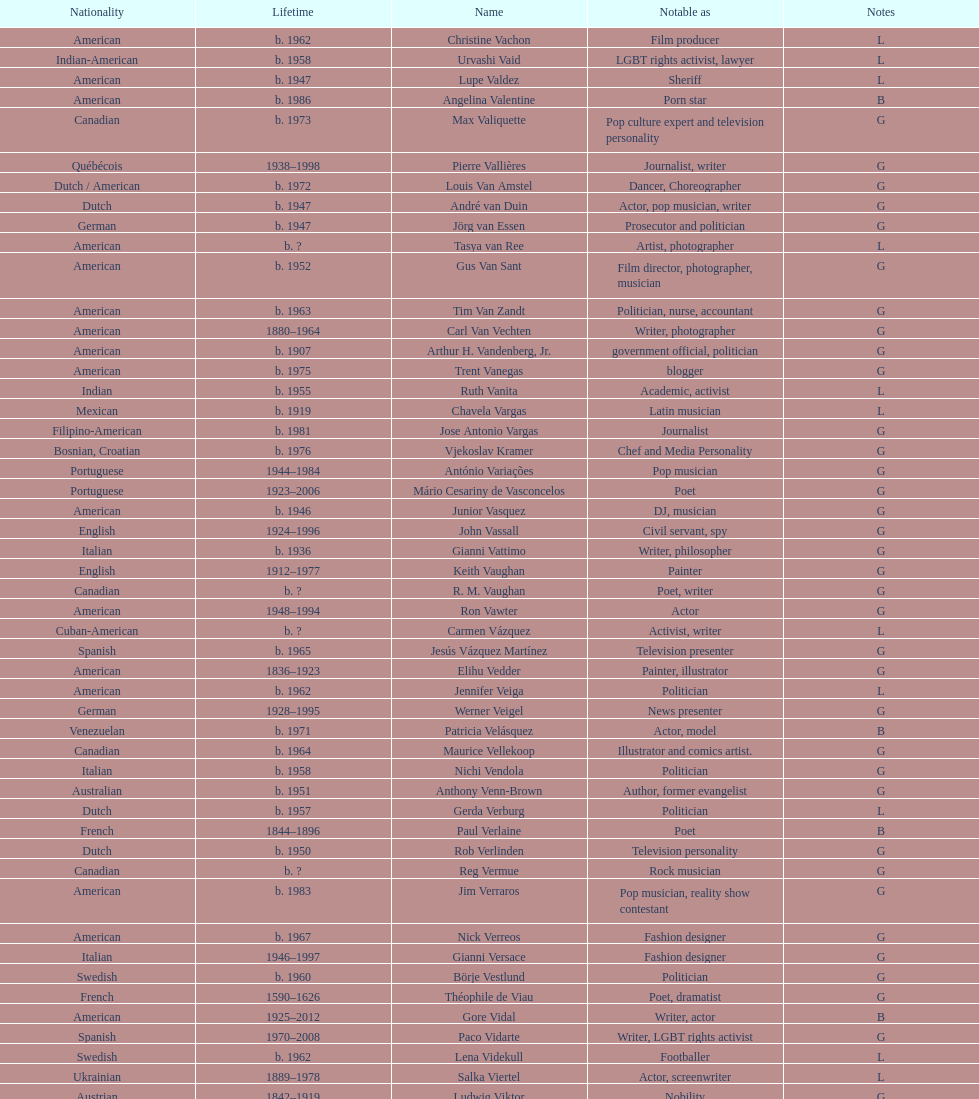Patricia velasquez and ron vawter both had what career? Actor. 